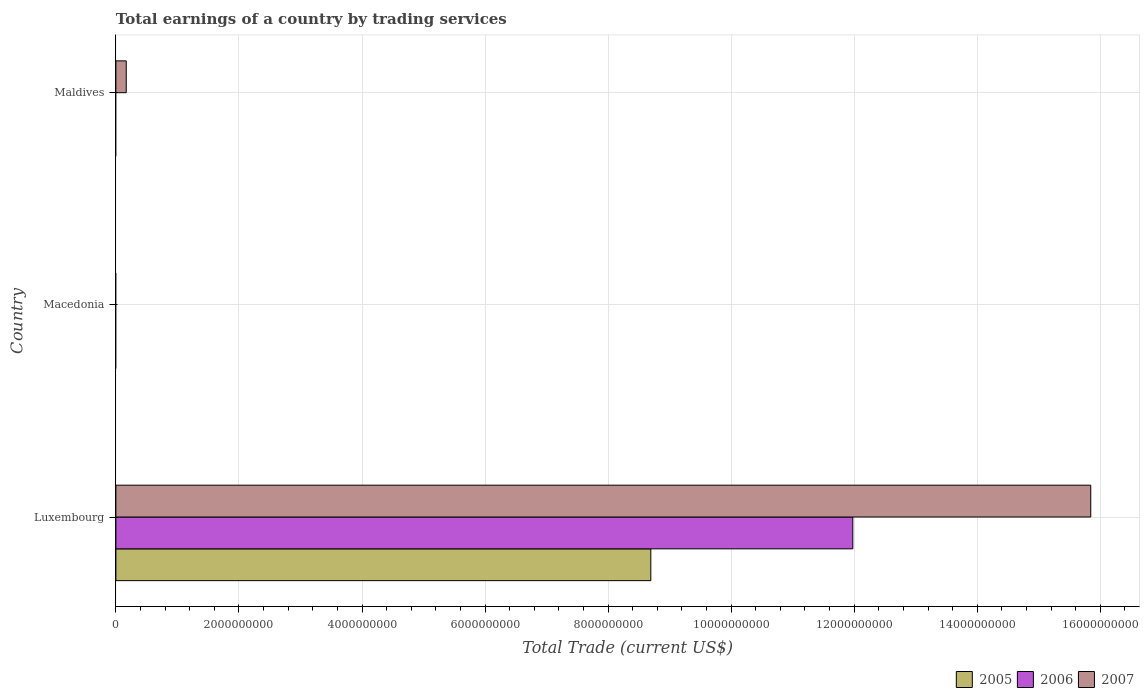How many different coloured bars are there?
Your answer should be very brief. 3. How many bars are there on the 2nd tick from the top?
Your answer should be compact. 0. How many bars are there on the 3rd tick from the bottom?
Make the answer very short. 1. What is the label of the 1st group of bars from the top?
Keep it short and to the point. Maldives. Across all countries, what is the maximum total earnings in 2007?
Offer a terse response. 1.58e+1. In which country was the total earnings in 2006 maximum?
Your answer should be very brief. Luxembourg. What is the total total earnings in 2006 in the graph?
Offer a terse response. 1.20e+1. What is the difference between the total earnings in 2007 in Luxembourg and that in Maldives?
Your response must be concise. 1.57e+1. What is the average total earnings in 2007 per country?
Offer a terse response. 5.34e+09. What is the difference between the total earnings in 2006 and total earnings in 2005 in Luxembourg?
Your answer should be compact. 3.28e+09. In how many countries, is the total earnings in 2005 greater than 7600000000 US$?
Make the answer very short. 1. What is the difference between the highest and the lowest total earnings in 2005?
Offer a very short reply. 8.69e+09. Is the sum of the total earnings in 2007 in Luxembourg and Maldives greater than the maximum total earnings in 2006 across all countries?
Offer a very short reply. Yes. What is the difference between two consecutive major ticks on the X-axis?
Offer a terse response. 2.00e+09. Does the graph contain any zero values?
Offer a terse response. Yes. What is the title of the graph?
Offer a very short reply. Total earnings of a country by trading services. What is the label or title of the X-axis?
Keep it short and to the point. Total Trade (current US$). What is the label or title of the Y-axis?
Your response must be concise. Country. What is the Total Trade (current US$) in 2005 in Luxembourg?
Your response must be concise. 8.69e+09. What is the Total Trade (current US$) in 2006 in Luxembourg?
Your answer should be very brief. 1.20e+1. What is the Total Trade (current US$) in 2007 in Luxembourg?
Your answer should be compact. 1.58e+1. What is the Total Trade (current US$) of 2006 in Macedonia?
Your response must be concise. 0. What is the Total Trade (current US$) in 2005 in Maldives?
Your answer should be compact. 0. What is the Total Trade (current US$) of 2007 in Maldives?
Offer a very short reply. 1.68e+08. Across all countries, what is the maximum Total Trade (current US$) in 2005?
Provide a short and direct response. 8.69e+09. Across all countries, what is the maximum Total Trade (current US$) in 2006?
Offer a very short reply. 1.20e+1. Across all countries, what is the maximum Total Trade (current US$) in 2007?
Give a very brief answer. 1.58e+1. Across all countries, what is the minimum Total Trade (current US$) in 2006?
Your answer should be very brief. 0. Across all countries, what is the minimum Total Trade (current US$) in 2007?
Give a very brief answer. 0. What is the total Total Trade (current US$) of 2005 in the graph?
Make the answer very short. 8.69e+09. What is the total Total Trade (current US$) in 2006 in the graph?
Your response must be concise. 1.20e+1. What is the total Total Trade (current US$) in 2007 in the graph?
Your answer should be very brief. 1.60e+1. What is the difference between the Total Trade (current US$) in 2007 in Luxembourg and that in Maldives?
Provide a short and direct response. 1.57e+1. What is the difference between the Total Trade (current US$) in 2005 in Luxembourg and the Total Trade (current US$) in 2007 in Maldives?
Make the answer very short. 8.53e+09. What is the difference between the Total Trade (current US$) of 2006 in Luxembourg and the Total Trade (current US$) of 2007 in Maldives?
Your response must be concise. 1.18e+1. What is the average Total Trade (current US$) of 2005 per country?
Offer a very short reply. 2.90e+09. What is the average Total Trade (current US$) in 2006 per country?
Keep it short and to the point. 3.99e+09. What is the average Total Trade (current US$) in 2007 per country?
Your response must be concise. 5.34e+09. What is the difference between the Total Trade (current US$) in 2005 and Total Trade (current US$) in 2006 in Luxembourg?
Your answer should be compact. -3.28e+09. What is the difference between the Total Trade (current US$) of 2005 and Total Trade (current US$) of 2007 in Luxembourg?
Make the answer very short. -7.15e+09. What is the difference between the Total Trade (current US$) of 2006 and Total Trade (current US$) of 2007 in Luxembourg?
Offer a very short reply. -3.87e+09. What is the ratio of the Total Trade (current US$) of 2007 in Luxembourg to that in Maldives?
Your response must be concise. 94.2. What is the difference between the highest and the lowest Total Trade (current US$) of 2005?
Your answer should be compact. 8.69e+09. What is the difference between the highest and the lowest Total Trade (current US$) in 2006?
Give a very brief answer. 1.20e+1. What is the difference between the highest and the lowest Total Trade (current US$) in 2007?
Provide a short and direct response. 1.58e+1. 